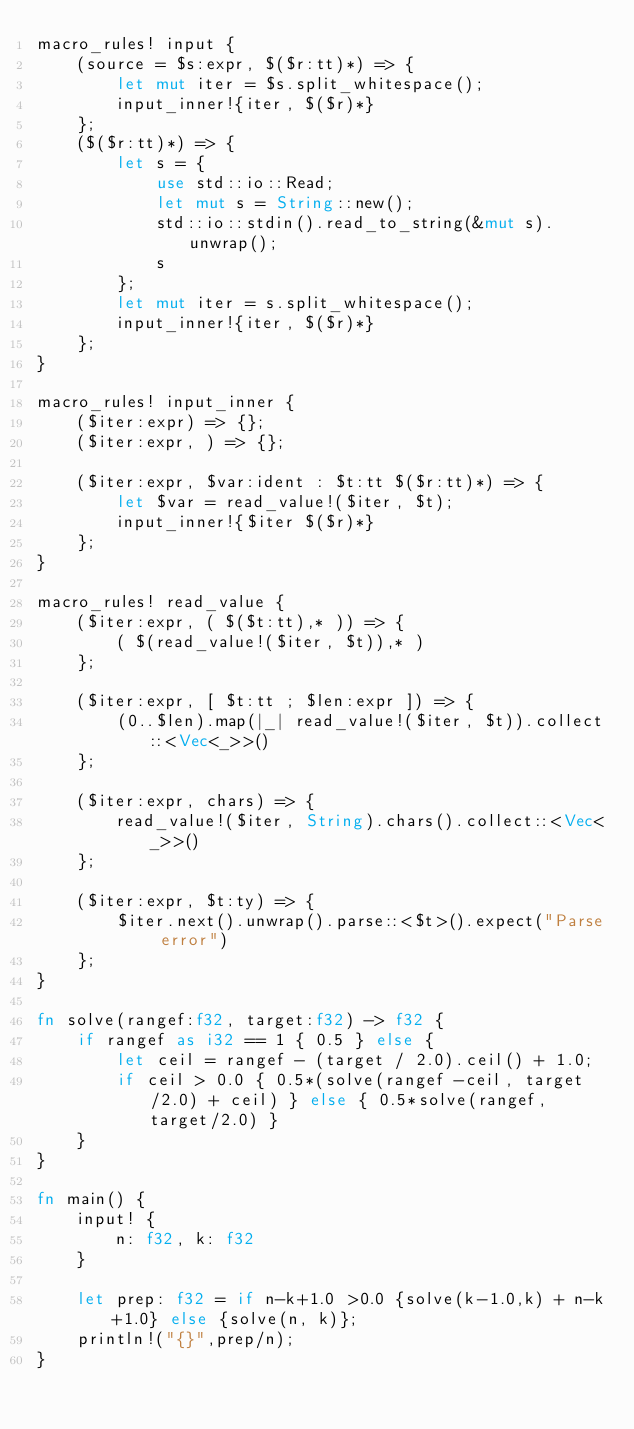<code> <loc_0><loc_0><loc_500><loc_500><_Rust_>macro_rules! input {
    (source = $s:expr, $($r:tt)*) => {
        let mut iter = $s.split_whitespace();
        input_inner!{iter, $($r)*}
    };
    ($($r:tt)*) => {
        let s = {
            use std::io::Read;
            let mut s = String::new();
            std::io::stdin().read_to_string(&mut s).unwrap();
            s
        };
        let mut iter = s.split_whitespace();
        input_inner!{iter, $($r)*}
    };
}

macro_rules! input_inner {
    ($iter:expr) => {};
    ($iter:expr, ) => {};

    ($iter:expr, $var:ident : $t:tt $($r:tt)*) => {
        let $var = read_value!($iter, $t);
        input_inner!{$iter $($r)*}
    };
}

macro_rules! read_value {
    ($iter:expr, ( $($t:tt),* )) => {
        ( $(read_value!($iter, $t)),* )
    };

    ($iter:expr, [ $t:tt ; $len:expr ]) => {
        (0..$len).map(|_| read_value!($iter, $t)).collect::<Vec<_>>()
    };

    ($iter:expr, chars) => {
        read_value!($iter, String).chars().collect::<Vec<_>>()
    };

    ($iter:expr, $t:ty) => {
        $iter.next().unwrap().parse::<$t>().expect("Parse error")
    };
}

fn solve(rangef:f32, target:f32) -> f32 {
    if rangef as i32 == 1 { 0.5 } else {
        let ceil = rangef - (target / 2.0).ceil() + 1.0;
        if ceil > 0.0 { 0.5*(solve(rangef -ceil, target/2.0) + ceil) } else { 0.5*solve(rangef, target/2.0) }
    }
}

fn main() {
    input! {
        n: f32, k: f32
    }

    let prep: f32 = if n-k+1.0 >0.0 {solve(k-1.0,k) + n-k+1.0} else {solve(n, k)};
    println!("{}",prep/n);
}
</code> 